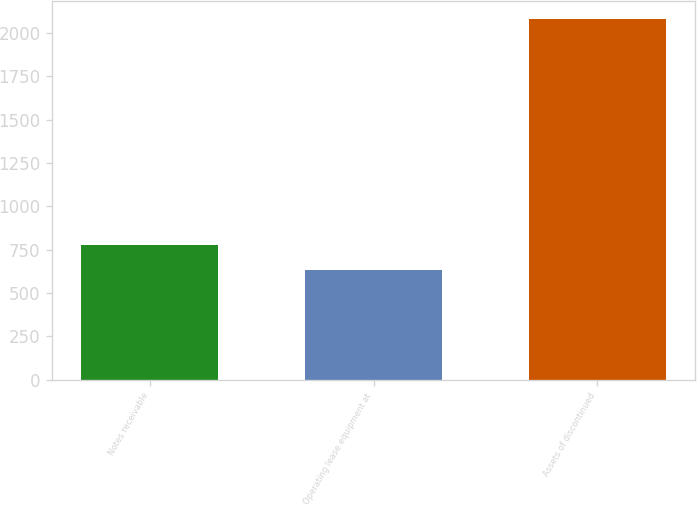<chart> <loc_0><loc_0><loc_500><loc_500><bar_chart><fcel>Notes receivable<fcel>Operating lease equipment at<fcel>Assets of discontinued<nl><fcel>778.8<fcel>634<fcel>2082<nl></chart> 